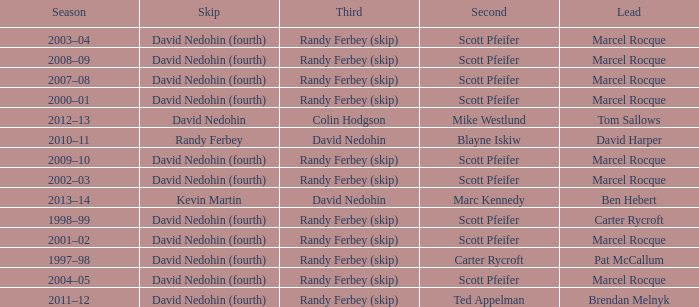Which Third has a Second of scott pfeifer? Randy Ferbey (skip), Randy Ferbey (skip), Randy Ferbey (skip), Randy Ferbey (skip), Randy Ferbey (skip), Randy Ferbey (skip), Randy Ferbey (skip), Randy Ferbey (skip), Randy Ferbey (skip). 